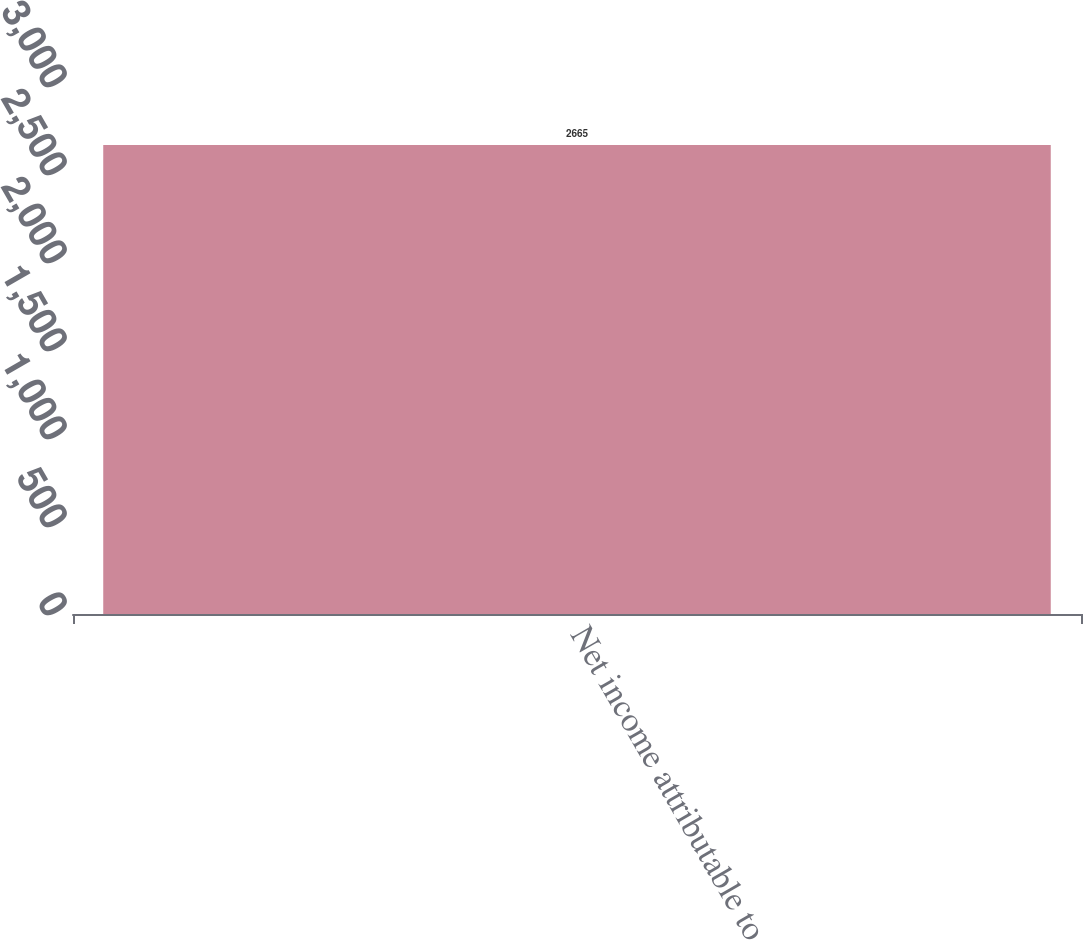Convert chart to OTSL. <chart><loc_0><loc_0><loc_500><loc_500><bar_chart><fcel>Net income attributable to<nl><fcel>2665<nl></chart> 